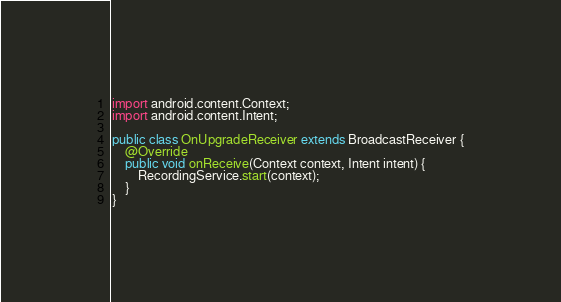<code> <loc_0><loc_0><loc_500><loc_500><_Java_>import android.content.Context;
import android.content.Intent;

public class OnUpgradeReceiver extends BroadcastReceiver {
    @Override
    public void onReceive(Context context, Intent intent) {
        RecordingService.start(context);
    }
}
</code> 